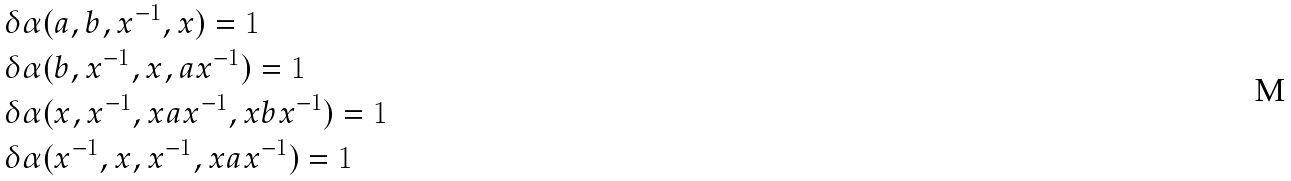Convert formula to latex. <formula><loc_0><loc_0><loc_500><loc_500>& \delta \alpha ( a , b , x ^ { - 1 } , x ) = 1 \\ & \delta \alpha ( b , x ^ { - 1 } , x , a x ^ { - 1 } ) = 1 \\ & \delta \alpha ( x , x ^ { - 1 } , x a x ^ { - 1 } , x b x ^ { - 1 } ) = 1 \\ & \delta \alpha ( x ^ { - 1 } , x , x ^ { - 1 } , x a x ^ { - 1 } ) = 1</formula> 